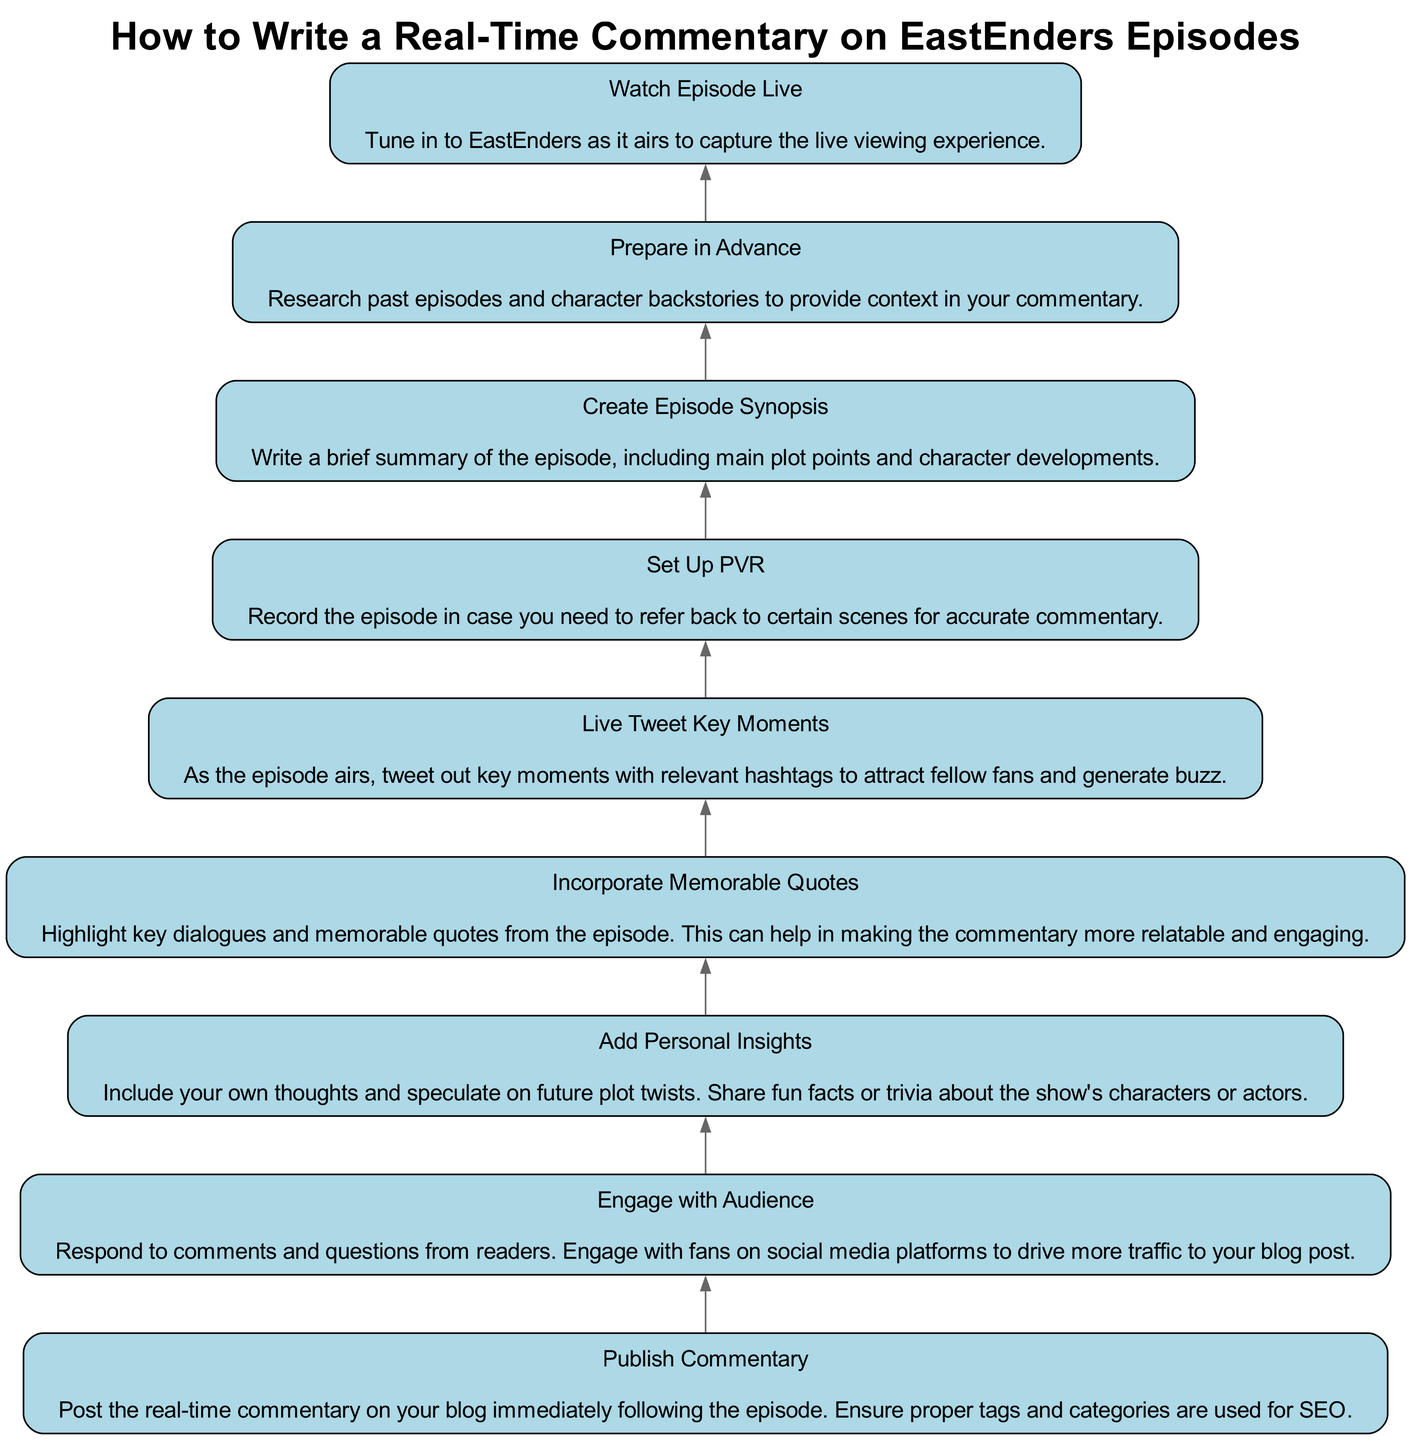What is the first step in writing a real-time commentary? The first step is to watch the episode live to capture the viewing experience, as indicated by the bottommost node in the flow chart.
Answer: Watch Episode Live How many elements are in the diagram? By counting the nodes listed in the diagram, there are a total of nine distinct elements or steps in the flow chart.
Answer: Nine Which step follows after preparing in advance? In the diagram, the step that follows preparing in advance is watching the episode live, indicating the flow of actions in the commentary process.
Answer: Watch Episode Live What is the last action to take in the process? The last action in the flow chart is to publish the commentary, which is the final step after engaging with the audience.
Answer: Publish Commentary What action is most closely associated with audience interaction? Engaging with the audience is directly related to audience interaction, as it involves responding to comments and questions from readers.
Answer: Engage with Audience What two steps directly precede the publication of commentary? The two steps that come before publishing the commentary are adding personal insights and incorporating memorable quotes, signifying the importance of these elements before final publication.
Answer: Add Personal Insights, Incorporate Memorable Quotes Which step involves social media engagement? The step that involves social media engagement is engaging with the audience, where you interact with fans and respond to comments.
Answer: Engage with Audience How is memorable content highlighted in the commentary process? Memorable content is highlighted by incorporating memorable quotes, which makes the commentary relatable and engaging for the audience.
Answer: Incorporate Memorable Quotes What is the purpose of setting up the PVR? The purpose of setting up the PVR is to record the episode for later reference, ensuring accurate commentary by revisiting key scenes if necessary.
Answer: Record the episode 